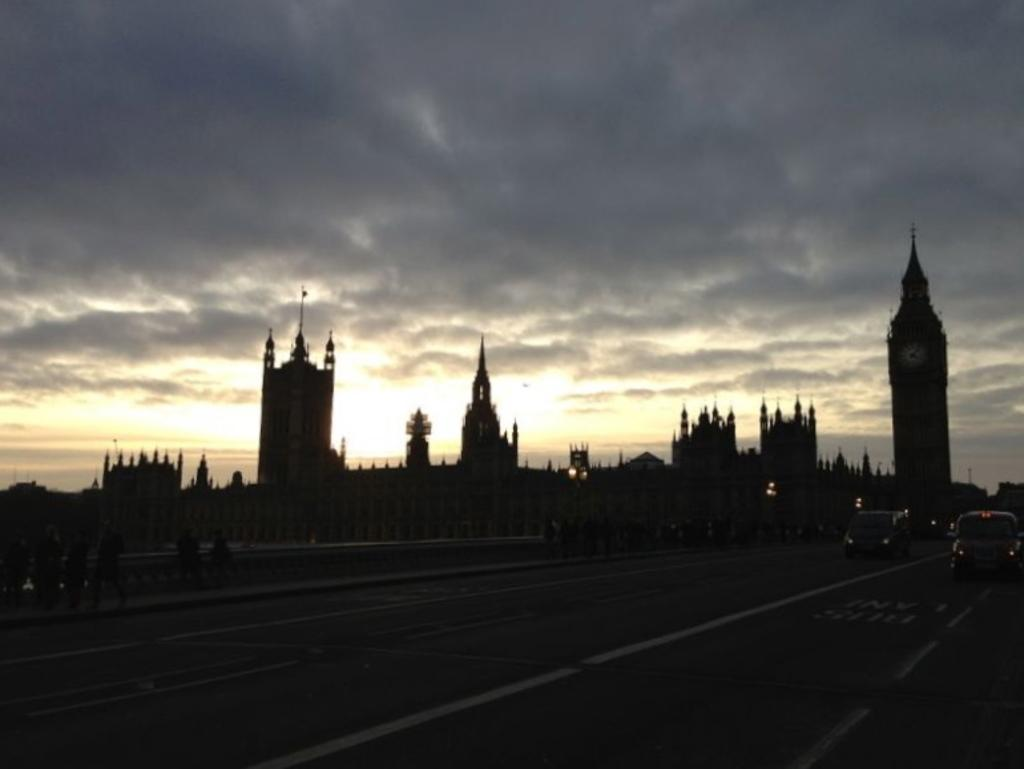What can be seen on the road in the image? There are vehicles on the road in the image. What type of structures are visible in the image? There are buildings in the image. Who or what else can be seen in the image? There are people in the image. What is visible in the background of the image? The sky is visible in the background of the image. What can be observed in the sky? Clouds are present in the sky. What type of baseball game is taking place in the image? There is no baseball game present in the image. Where is the party happening in the image? There is no party depicted in the image. 